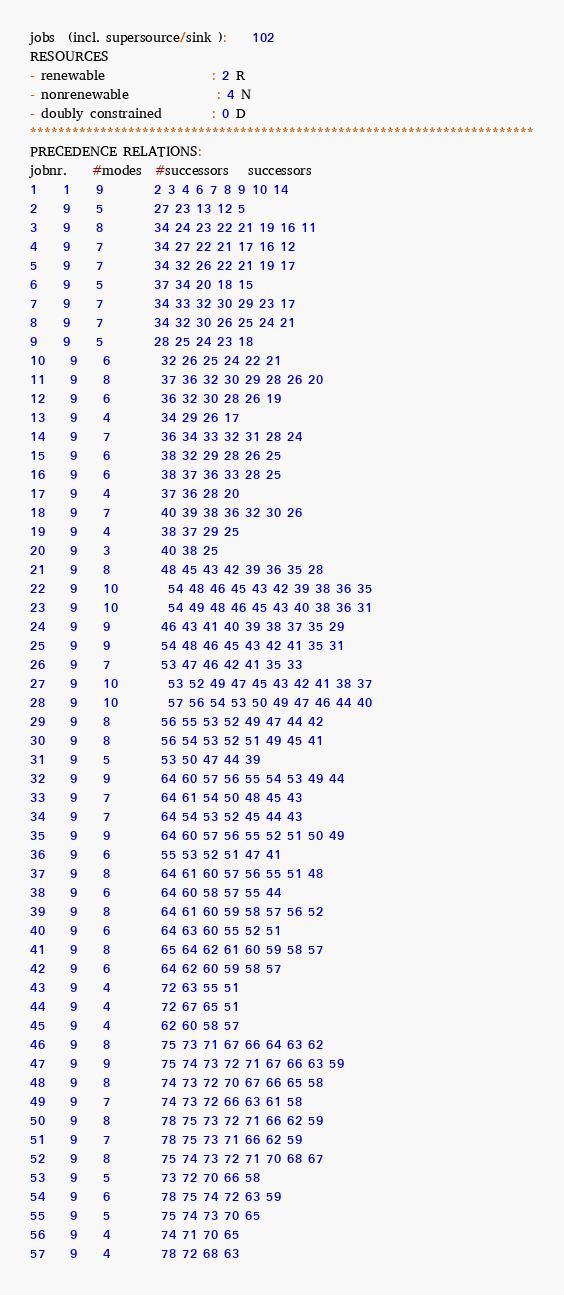Convert code to text. <code><loc_0><loc_0><loc_500><loc_500><_ObjectiveC_>jobs  (incl. supersource/sink ):	102
RESOURCES
- renewable                 : 2 R
- nonrenewable              : 4 N
- doubly constrained        : 0 D
************************************************************************
PRECEDENCE RELATIONS:
jobnr.    #modes  #successors   successors
1	1	9		2 3 4 6 7 8 9 10 14 
2	9	5		27 23 13 12 5 
3	9	8		34 24 23 22 21 19 16 11 
4	9	7		34 27 22 21 17 16 12 
5	9	7		34 32 26 22 21 19 17 
6	9	5		37 34 20 18 15 
7	9	7		34 33 32 30 29 23 17 
8	9	7		34 32 30 26 25 24 21 
9	9	5		28 25 24 23 18 
10	9	6		32 26 25 24 22 21 
11	9	8		37 36 32 30 29 28 26 20 
12	9	6		36 32 30 28 26 19 
13	9	4		34 29 26 17 
14	9	7		36 34 33 32 31 28 24 
15	9	6		38 32 29 28 26 25 
16	9	6		38 37 36 33 28 25 
17	9	4		37 36 28 20 
18	9	7		40 39 38 36 32 30 26 
19	9	4		38 37 29 25 
20	9	3		40 38 25 
21	9	8		48 45 43 42 39 36 35 28 
22	9	10		54 48 46 45 43 42 39 38 36 35 
23	9	10		54 49 48 46 45 43 40 38 36 31 
24	9	9		46 43 41 40 39 38 37 35 29 
25	9	9		54 48 46 45 43 42 41 35 31 
26	9	7		53 47 46 42 41 35 33 
27	9	10		53 52 49 47 45 43 42 41 38 37 
28	9	10		57 56 54 53 50 49 47 46 44 40 
29	9	8		56 55 53 52 49 47 44 42 
30	9	8		56 54 53 52 51 49 45 41 
31	9	5		53 50 47 44 39 
32	9	9		64 60 57 56 55 54 53 49 44 
33	9	7		64 61 54 50 48 45 43 
34	9	7		64 54 53 52 45 44 43 
35	9	9		64 60 57 56 55 52 51 50 49 
36	9	6		55 53 52 51 47 41 
37	9	8		64 61 60 57 56 55 51 48 
38	9	6		64 60 58 57 55 44 
39	9	8		64 61 60 59 58 57 56 52 
40	9	6		64 63 60 55 52 51 
41	9	8		65 64 62 61 60 59 58 57 
42	9	6		64 62 60 59 58 57 
43	9	4		72 63 55 51 
44	9	4		72 67 65 51 
45	9	4		62 60 58 57 
46	9	8		75 73 71 67 66 64 63 62 
47	9	9		75 74 73 72 71 67 66 63 59 
48	9	8		74 73 72 70 67 66 65 58 
49	9	7		74 73 72 66 63 61 58 
50	9	8		78 75 73 72 71 66 62 59 
51	9	7		78 75 73 71 66 62 59 
52	9	8		75 74 73 72 71 70 68 67 
53	9	5		73 72 70 66 58 
54	9	6		78 75 74 72 63 59 
55	9	5		75 74 73 70 65 
56	9	4		74 71 70 65 
57	9	4		78 72 68 63 </code> 